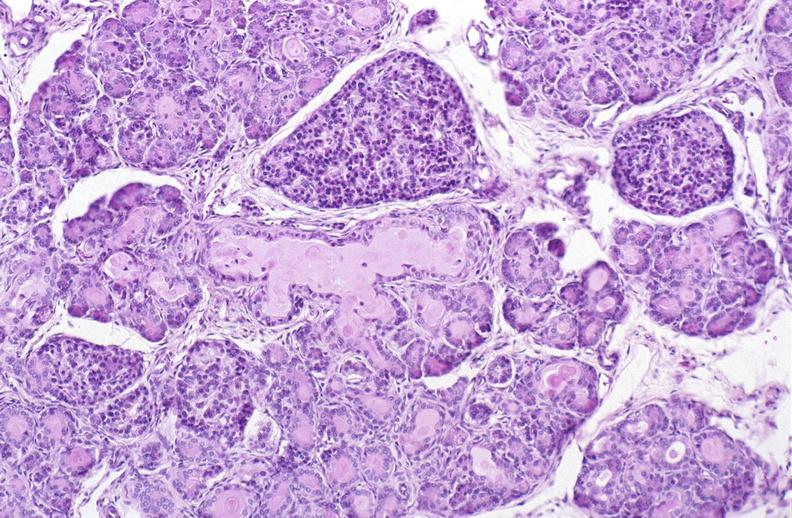does this image show cystic fibrosis?
Answer the question using a single word or phrase. Yes 